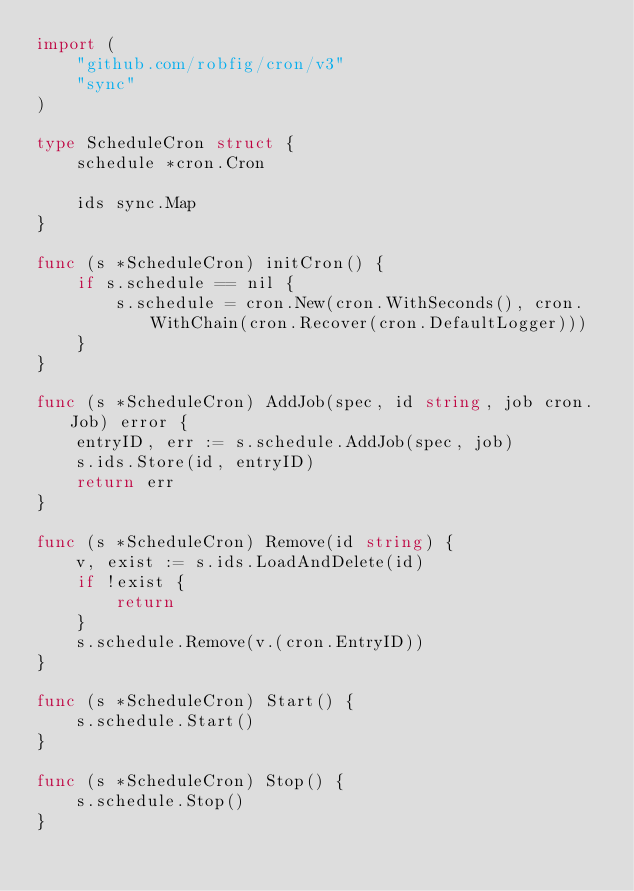<code> <loc_0><loc_0><loc_500><loc_500><_Go_>import (
	"github.com/robfig/cron/v3"
	"sync"
)

type ScheduleCron struct {
	schedule *cron.Cron

	ids sync.Map
}

func (s *ScheduleCron) initCron() {
	if s.schedule == nil {
		s.schedule = cron.New(cron.WithSeconds(), cron.WithChain(cron.Recover(cron.DefaultLogger)))
	}
}

func (s *ScheduleCron) AddJob(spec, id string, job cron.Job) error {
	entryID, err := s.schedule.AddJob(spec, job)
	s.ids.Store(id, entryID)
	return err
}

func (s *ScheduleCron) Remove(id string) {
	v, exist := s.ids.LoadAndDelete(id)
	if !exist {
		return
	}
	s.schedule.Remove(v.(cron.EntryID))
}

func (s *ScheduleCron) Start() {
	s.schedule.Start()
}

func (s *ScheduleCron) Stop() {
	s.schedule.Stop()
}
</code> 